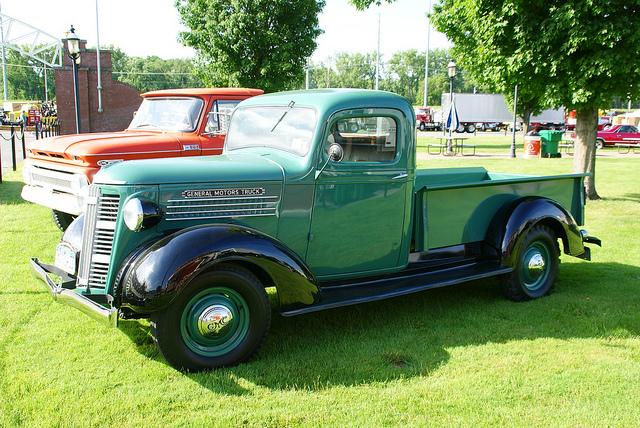What colors are the wheel caps?
Write a very short answer. Silver. What color is the older truck?
Answer briefly. Green. What kind of truck is in the picture?
Keep it brief. Old. Is the truck loaded with people?
Answer briefly. No. What color is the front of the truck?
Short answer required. Green. Does the truck have big tires?
Quick response, please. Yes. Why is this rescue vehicle in the field?
Short answer required. Display. Are the trucks in motion?
Keep it brief. No. Were these trucks assembled in the 21 century?
Concise answer only. No. What color are the hubcaps?
Keep it brief. Silver. 